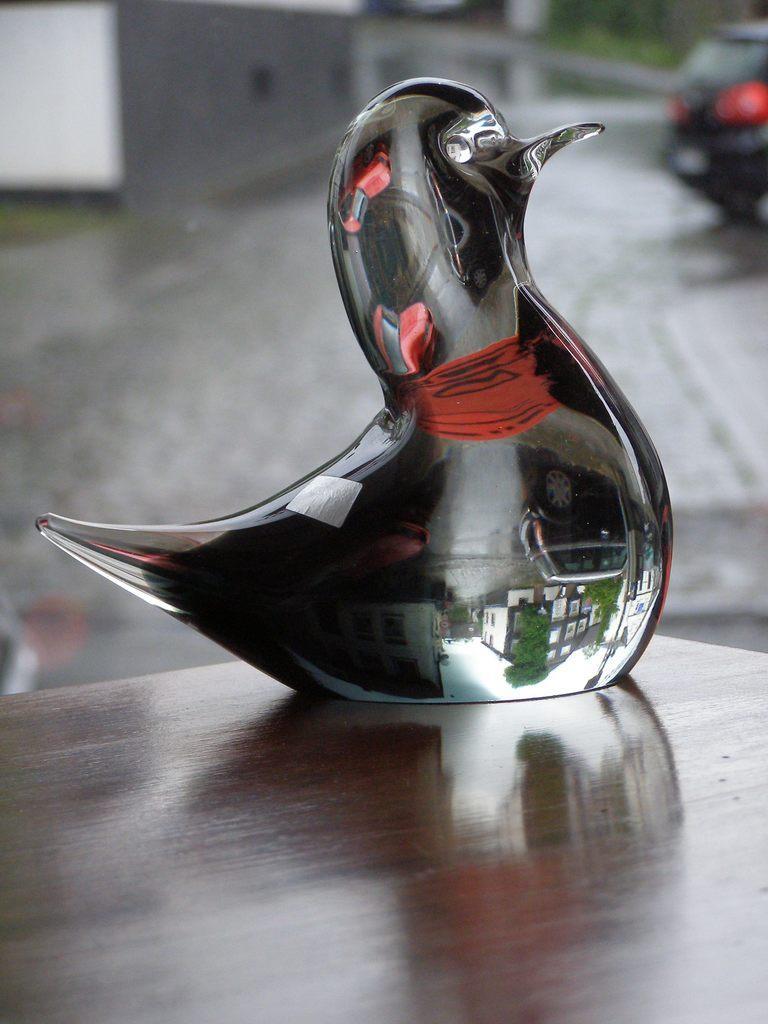In one or two sentences, can you explain what this image depicts? In this image there is a bird structure made from glass. 